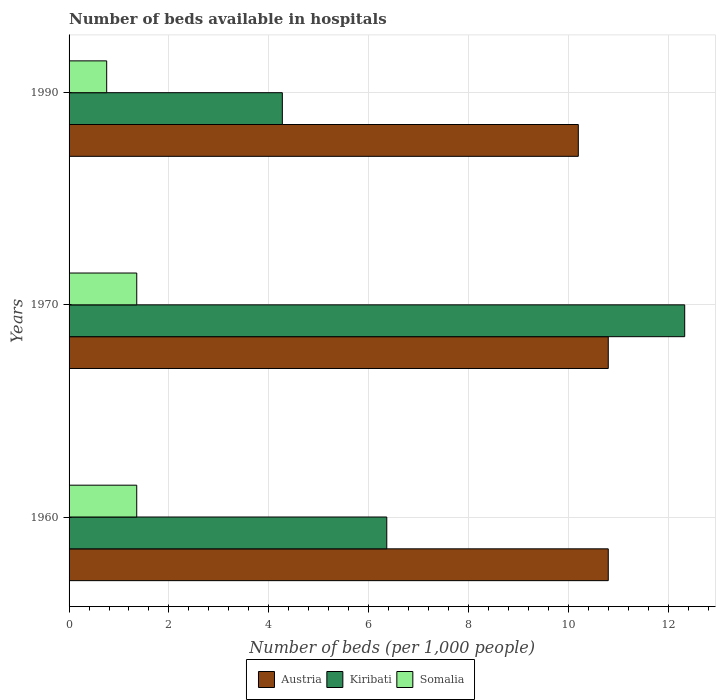Are the number of bars on each tick of the Y-axis equal?
Offer a very short reply. Yes. How many bars are there on the 2nd tick from the top?
Offer a terse response. 3. How many bars are there on the 2nd tick from the bottom?
Keep it short and to the point. 3. In how many cases, is the number of bars for a given year not equal to the number of legend labels?
Your answer should be compact. 0. What is the number of beds in the hospiatls of in Austria in 1970?
Offer a terse response. 10.8. Across all years, what is the maximum number of beds in the hospiatls of in Kiribati?
Give a very brief answer. 12.33. Across all years, what is the minimum number of beds in the hospiatls of in Austria?
Your answer should be very brief. 10.2. In which year was the number of beds in the hospiatls of in Somalia maximum?
Offer a very short reply. 1970. In which year was the number of beds in the hospiatls of in Somalia minimum?
Offer a very short reply. 1990. What is the total number of beds in the hospiatls of in Kiribati in the graph?
Your response must be concise. 22.97. What is the difference between the number of beds in the hospiatls of in Austria in 1970 and that in 1990?
Provide a succinct answer. 0.6. What is the difference between the number of beds in the hospiatls of in Kiribati in 1990 and the number of beds in the hospiatls of in Somalia in 1970?
Provide a short and direct response. 2.92. What is the average number of beds in the hospiatls of in Kiribati per year?
Make the answer very short. 7.66. In the year 1970, what is the difference between the number of beds in the hospiatls of in Somalia and number of beds in the hospiatls of in Austria?
Keep it short and to the point. -9.44. In how many years, is the number of beds in the hospiatls of in Kiribati greater than 9.2 ?
Your answer should be compact. 1. What is the ratio of the number of beds in the hospiatls of in Austria in 1960 to that in 1990?
Your response must be concise. 1.06. What is the difference between the highest and the second highest number of beds in the hospiatls of in Somalia?
Your answer should be compact. 0. What is the difference between the highest and the lowest number of beds in the hospiatls of in Somalia?
Offer a very short reply. 0.6. In how many years, is the number of beds in the hospiatls of in Somalia greater than the average number of beds in the hospiatls of in Somalia taken over all years?
Your answer should be compact. 2. What does the 1st bar from the top in 1990 represents?
Offer a very short reply. Somalia. What does the 1st bar from the bottom in 1960 represents?
Make the answer very short. Austria. Is it the case that in every year, the sum of the number of beds in the hospiatls of in Somalia and number of beds in the hospiatls of in Austria is greater than the number of beds in the hospiatls of in Kiribati?
Provide a succinct answer. No. How many bars are there?
Offer a very short reply. 9. How many years are there in the graph?
Offer a terse response. 3. What is the difference between two consecutive major ticks on the X-axis?
Provide a short and direct response. 2. Are the values on the major ticks of X-axis written in scientific E-notation?
Give a very brief answer. No. Does the graph contain any zero values?
Your answer should be compact. No. Does the graph contain grids?
Make the answer very short. Yes. Where does the legend appear in the graph?
Your answer should be very brief. Bottom center. How are the legend labels stacked?
Make the answer very short. Horizontal. What is the title of the graph?
Provide a succinct answer. Number of beds available in hospitals. What is the label or title of the X-axis?
Provide a short and direct response. Number of beds (per 1,0 people). What is the label or title of the Y-axis?
Ensure brevity in your answer.  Years. What is the Number of beds (per 1,000 people) in Austria in 1960?
Ensure brevity in your answer.  10.8. What is the Number of beds (per 1,000 people) of Kiribati in 1960?
Offer a very short reply. 6.36. What is the Number of beds (per 1,000 people) in Somalia in 1960?
Offer a terse response. 1.36. What is the Number of beds (per 1,000 people) in Austria in 1970?
Keep it short and to the point. 10.8. What is the Number of beds (per 1,000 people) in Kiribati in 1970?
Keep it short and to the point. 12.33. What is the Number of beds (per 1,000 people) in Somalia in 1970?
Offer a terse response. 1.36. What is the Number of beds (per 1,000 people) in Austria in 1990?
Provide a succinct answer. 10.2. What is the Number of beds (per 1,000 people) in Kiribati in 1990?
Your answer should be very brief. 4.27. What is the Number of beds (per 1,000 people) in Somalia in 1990?
Your answer should be very brief. 0.75. Across all years, what is the maximum Number of beds (per 1,000 people) of Austria?
Keep it short and to the point. 10.8. Across all years, what is the maximum Number of beds (per 1,000 people) in Kiribati?
Your answer should be very brief. 12.33. Across all years, what is the maximum Number of beds (per 1,000 people) in Somalia?
Offer a terse response. 1.36. Across all years, what is the minimum Number of beds (per 1,000 people) in Austria?
Provide a short and direct response. 10.2. Across all years, what is the minimum Number of beds (per 1,000 people) of Kiribati?
Offer a terse response. 4.27. Across all years, what is the minimum Number of beds (per 1,000 people) in Somalia?
Offer a very short reply. 0.75. What is the total Number of beds (per 1,000 people) in Austria in the graph?
Provide a succinct answer. 31.8. What is the total Number of beds (per 1,000 people) of Kiribati in the graph?
Provide a short and direct response. 22.97. What is the total Number of beds (per 1,000 people) in Somalia in the graph?
Make the answer very short. 3.46. What is the difference between the Number of beds (per 1,000 people) of Austria in 1960 and that in 1970?
Provide a succinct answer. 0. What is the difference between the Number of beds (per 1,000 people) in Kiribati in 1960 and that in 1970?
Provide a succinct answer. -5.97. What is the difference between the Number of beds (per 1,000 people) of Somalia in 1960 and that in 1970?
Make the answer very short. -0. What is the difference between the Number of beds (per 1,000 people) of Kiribati in 1960 and that in 1990?
Your answer should be very brief. 2.09. What is the difference between the Number of beds (per 1,000 people) of Somalia in 1960 and that in 1990?
Give a very brief answer. 0.6. What is the difference between the Number of beds (per 1,000 people) in Austria in 1970 and that in 1990?
Offer a terse response. 0.6. What is the difference between the Number of beds (per 1,000 people) in Kiribati in 1970 and that in 1990?
Your response must be concise. 8.06. What is the difference between the Number of beds (per 1,000 people) of Somalia in 1970 and that in 1990?
Your response must be concise. 0.6. What is the difference between the Number of beds (per 1,000 people) of Austria in 1960 and the Number of beds (per 1,000 people) of Kiribati in 1970?
Give a very brief answer. -1.53. What is the difference between the Number of beds (per 1,000 people) in Austria in 1960 and the Number of beds (per 1,000 people) in Somalia in 1970?
Give a very brief answer. 9.44. What is the difference between the Number of beds (per 1,000 people) in Kiribati in 1960 and the Number of beds (per 1,000 people) in Somalia in 1970?
Offer a very short reply. 5.01. What is the difference between the Number of beds (per 1,000 people) in Austria in 1960 and the Number of beds (per 1,000 people) in Kiribati in 1990?
Make the answer very short. 6.53. What is the difference between the Number of beds (per 1,000 people) in Austria in 1960 and the Number of beds (per 1,000 people) in Somalia in 1990?
Offer a terse response. 10.05. What is the difference between the Number of beds (per 1,000 people) in Kiribati in 1960 and the Number of beds (per 1,000 people) in Somalia in 1990?
Keep it short and to the point. 5.61. What is the difference between the Number of beds (per 1,000 people) in Austria in 1970 and the Number of beds (per 1,000 people) in Kiribati in 1990?
Offer a terse response. 6.53. What is the difference between the Number of beds (per 1,000 people) of Austria in 1970 and the Number of beds (per 1,000 people) of Somalia in 1990?
Offer a very short reply. 10.05. What is the difference between the Number of beds (per 1,000 people) in Kiribati in 1970 and the Number of beds (per 1,000 people) in Somalia in 1990?
Give a very brief answer. 11.58. What is the average Number of beds (per 1,000 people) of Austria per year?
Offer a terse response. 10.6. What is the average Number of beds (per 1,000 people) in Kiribati per year?
Keep it short and to the point. 7.66. What is the average Number of beds (per 1,000 people) of Somalia per year?
Ensure brevity in your answer.  1.15. In the year 1960, what is the difference between the Number of beds (per 1,000 people) in Austria and Number of beds (per 1,000 people) in Kiribati?
Offer a very short reply. 4.44. In the year 1960, what is the difference between the Number of beds (per 1,000 people) of Austria and Number of beds (per 1,000 people) of Somalia?
Make the answer very short. 9.44. In the year 1960, what is the difference between the Number of beds (per 1,000 people) of Kiribati and Number of beds (per 1,000 people) of Somalia?
Your response must be concise. 5.01. In the year 1970, what is the difference between the Number of beds (per 1,000 people) in Austria and Number of beds (per 1,000 people) in Kiribati?
Offer a terse response. -1.53. In the year 1970, what is the difference between the Number of beds (per 1,000 people) of Austria and Number of beds (per 1,000 people) of Somalia?
Keep it short and to the point. 9.44. In the year 1970, what is the difference between the Number of beds (per 1,000 people) in Kiribati and Number of beds (per 1,000 people) in Somalia?
Provide a short and direct response. 10.98. In the year 1990, what is the difference between the Number of beds (per 1,000 people) in Austria and Number of beds (per 1,000 people) in Kiribati?
Keep it short and to the point. 5.93. In the year 1990, what is the difference between the Number of beds (per 1,000 people) in Austria and Number of beds (per 1,000 people) in Somalia?
Provide a succinct answer. 9.45. In the year 1990, what is the difference between the Number of beds (per 1,000 people) in Kiribati and Number of beds (per 1,000 people) in Somalia?
Your response must be concise. 3.52. What is the ratio of the Number of beds (per 1,000 people) of Kiribati in 1960 to that in 1970?
Give a very brief answer. 0.52. What is the ratio of the Number of beds (per 1,000 people) in Austria in 1960 to that in 1990?
Keep it short and to the point. 1.06. What is the ratio of the Number of beds (per 1,000 people) in Kiribati in 1960 to that in 1990?
Make the answer very short. 1.49. What is the ratio of the Number of beds (per 1,000 people) in Somalia in 1960 to that in 1990?
Provide a short and direct response. 1.8. What is the ratio of the Number of beds (per 1,000 people) of Austria in 1970 to that in 1990?
Your answer should be compact. 1.06. What is the ratio of the Number of beds (per 1,000 people) of Kiribati in 1970 to that in 1990?
Offer a terse response. 2.89. What is the ratio of the Number of beds (per 1,000 people) of Somalia in 1970 to that in 1990?
Your response must be concise. 1.8. What is the difference between the highest and the second highest Number of beds (per 1,000 people) of Austria?
Your answer should be very brief. 0. What is the difference between the highest and the second highest Number of beds (per 1,000 people) of Kiribati?
Your response must be concise. 5.97. What is the difference between the highest and the second highest Number of beds (per 1,000 people) of Somalia?
Provide a short and direct response. 0. What is the difference between the highest and the lowest Number of beds (per 1,000 people) in Kiribati?
Your response must be concise. 8.06. What is the difference between the highest and the lowest Number of beds (per 1,000 people) in Somalia?
Provide a succinct answer. 0.6. 